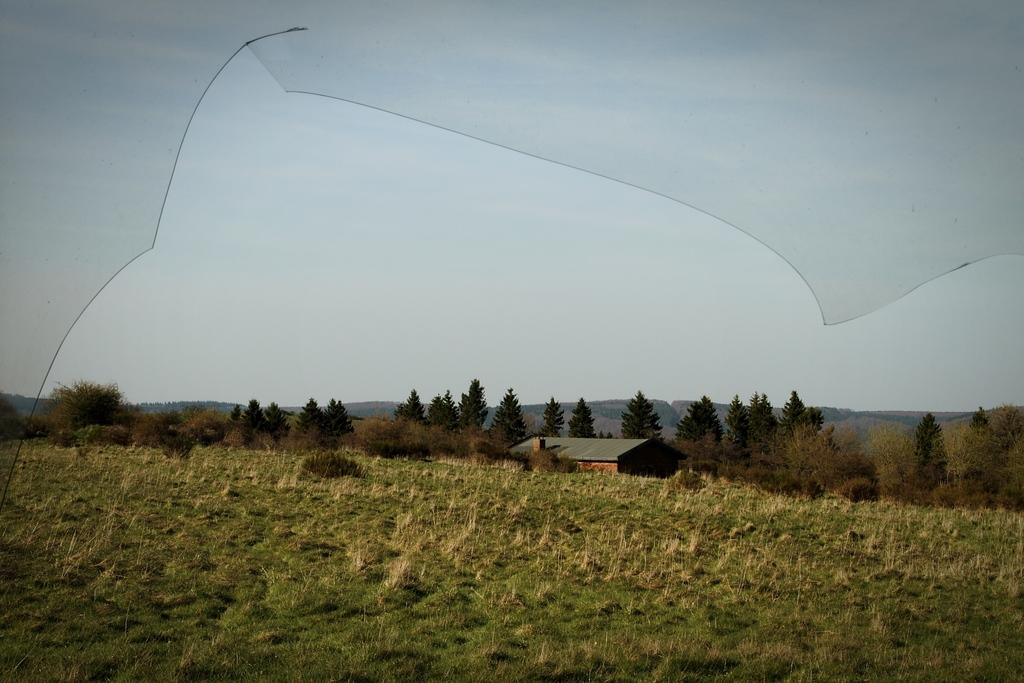What type of plant is in the foreground of the image? There is a grass plant in the image. What else can be seen in the image besides the grass plant? There are crops, plants, trees, and a house in the background of the image. What is visible in the sky in the image? The sky is visible in the background of the image. What advice is the grass plant giving to the crops in the image? There is no indication in the image that the grass plant is giving advice to the crops, as plants do not communicate in this manner. 